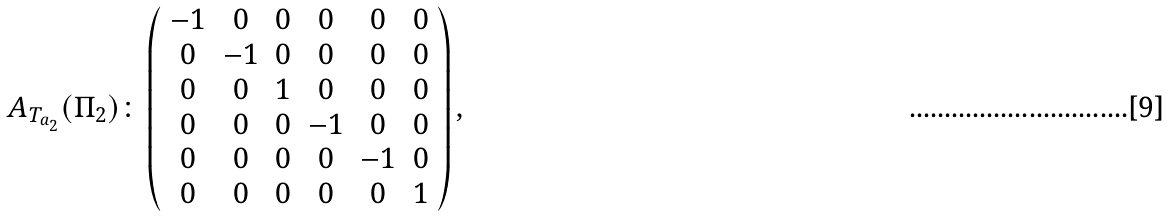Convert formula to latex. <formula><loc_0><loc_0><loc_500><loc_500>A _ { T _ { a _ { 2 } } } ( \Pi _ { 2 } ) \colon \left ( \begin{array} { c c c c c c } - 1 & 0 & 0 & 0 & 0 & 0 \\ 0 & - 1 & 0 & 0 & 0 & 0 \\ 0 & 0 & 1 & 0 & 0 & 0 \\ 0 & 0 & 0 & - 1 & 0 & 0 \\ 0 & 0 & 0 & 0 & - 1 & 0 \\ 0 & 0 & 0 & 0 & 0 & 1 \end{array} \right ) ,</formula> 